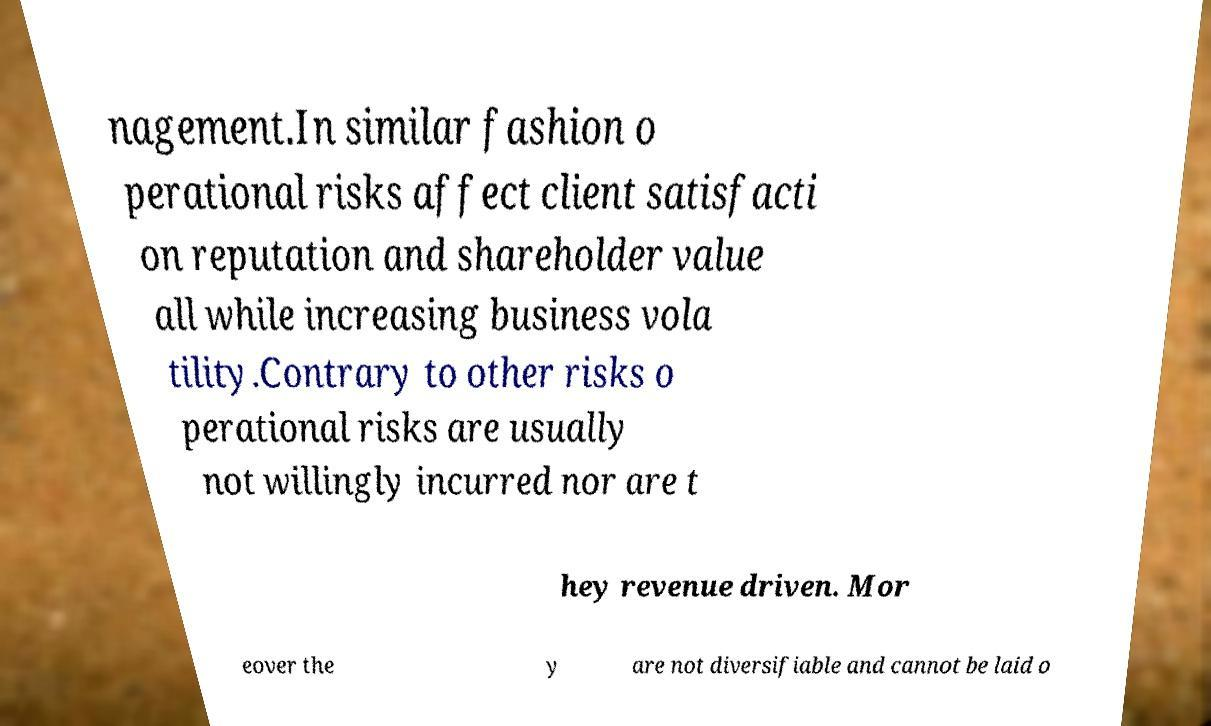Can you read and provide the text displayed in the image?This photo seems to have some interesting text. Can you extract and type it out for me? nagement.In similar fashion o perational risks affect client satisfacti on reputation and shareholder value all while increasing business vola tility.Contrary to other risks o perational risks are usually not willingly incurred nor are t hey revenue driven. Mor eover the y are not diversifiable and cannot be laid o 